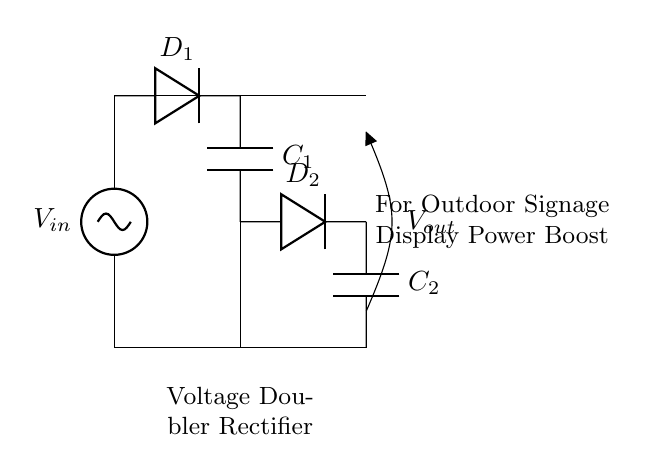What is the input voltage of this circuit? The input voltage is represented as V_in at the left side of the diagram, indicating the voltage supplied to the circuit for its operation.
Answer: V_in What type of capacitors are used in the circuit? The diagram shows two capacitors labeled as C_1 and C_2, which are typically used for energy storage and filtering in rectifier circuits.
Answer: Capacitors How many diodes are present in the rectifier circuit? The circuit includes two diodes labeled D_1 and D_2, which are used to allow current to flow in one direction, effectively rectifying the AC input voltage into a DC output.
Answer: Two What is the purpose of the voltage doubler in this circuit? The voltage doubler configuration is designed to increase the output voltage (V_out) to twice that of the input voltage (V_in), delivering a higher voltage suitable for driving outdoor signage displays.
Answer: Boost voltage What is the output voltage relative to the input voltage? The output voltage (V_out) is essentially double the input voltage (V_in) due to the specific arrangement of capacitors and diodes in the voltage doubler configuration.
Answer: Double What happens to the output voltage when the input voltage increases? When the input voltage (V_in) increases, the output voltage (V_out) will also increase proportionally, since the voltage doubler design aims to maintain the output as twice the input voltage level.
Answer: Increases proportionally 